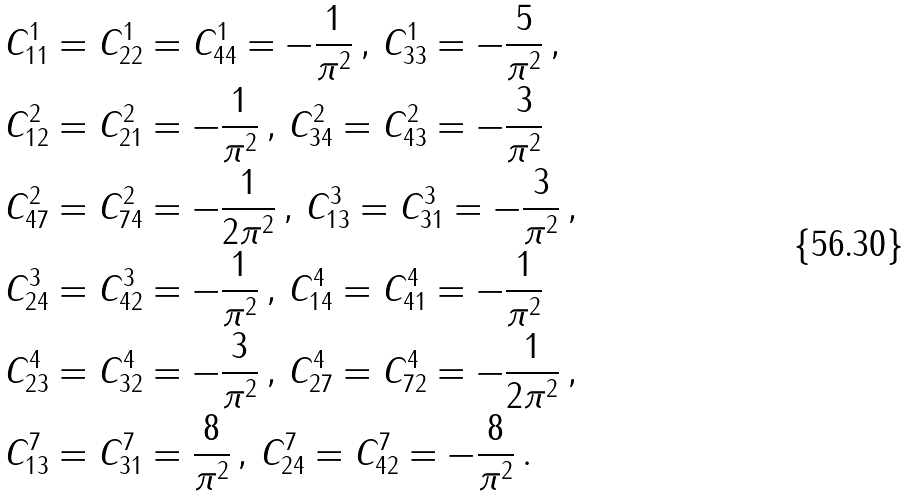<formula> <loc_0><loc_0><loc_500><loc_500>& C _ { 1 1 } ^ { 1 } = C _ { 2 2 } ^ { 1 } = C _ { 4 4 } ^ { 1 } = - \frac { 1 } { \pi ^ { 2 } } \, , \, C _ { 3 3 } ^ { 1 } = - \frac { 5 } { \pi ^ { 2 } } \, , \\ & C _ { 1 2 } ^ { 2 } = C _ { 2 1 } ^ { 2 } = - \frac { 1 } { \pi ^ { 2 } } \, , \, C _ { 3 4 } ^ { 2 } = C _ { 4 3 } ^ { 2 } = - \frac { 3 } { \pi ^ { 2 } } \\ & C _ { 4 7 } ^ { 2 } = C _ { 7 4 } ^ { 2 } = - \frac { 1 } { 2 \pi ^ { 2 } } \, , \, C _ { 1 3 } ^ { 3 } = C _ { 3 1 } ^ { 3 } = - \frac { 3 } { \pi ^ { 2 } } \, , \\ & C _ { 2 4 } ^ { 3 } = C _ { 4 2 } ^ { 3 } = - \frac { 1 } { \pi ^ { 2 } } \, , \, C _ { 1 4 } ^ { 4 } = C _ { 4 1 } ^ { 4 } = - \frac { 1 } { \pi ^ { 2 } } \, \\ & C _ { 2 3 } ^ { 4 } = C _ { 3 2 } ^ { 4 } = - \frac { 3 } { \pi ^ { 2 } } \, , \, C _ { 2 7 } ^ { 4 } = C _ { 7 2 } ^ { 4 } = - \frac { 1 } { 2 \pi ^ { 2 } } \, , \\ & C _ { 1 3 } ^ { 7 } = C _ { 3 1 } ^ { 7 } = \frac { 8 } { \pi ^ { 2 } } \, , \, C _ { 2 4 } ^ { 7 } = C _ { 4 2 } ^ { 7 } = - \frac { 8 } { \pi ^ { 2 } } \, .</formula> 